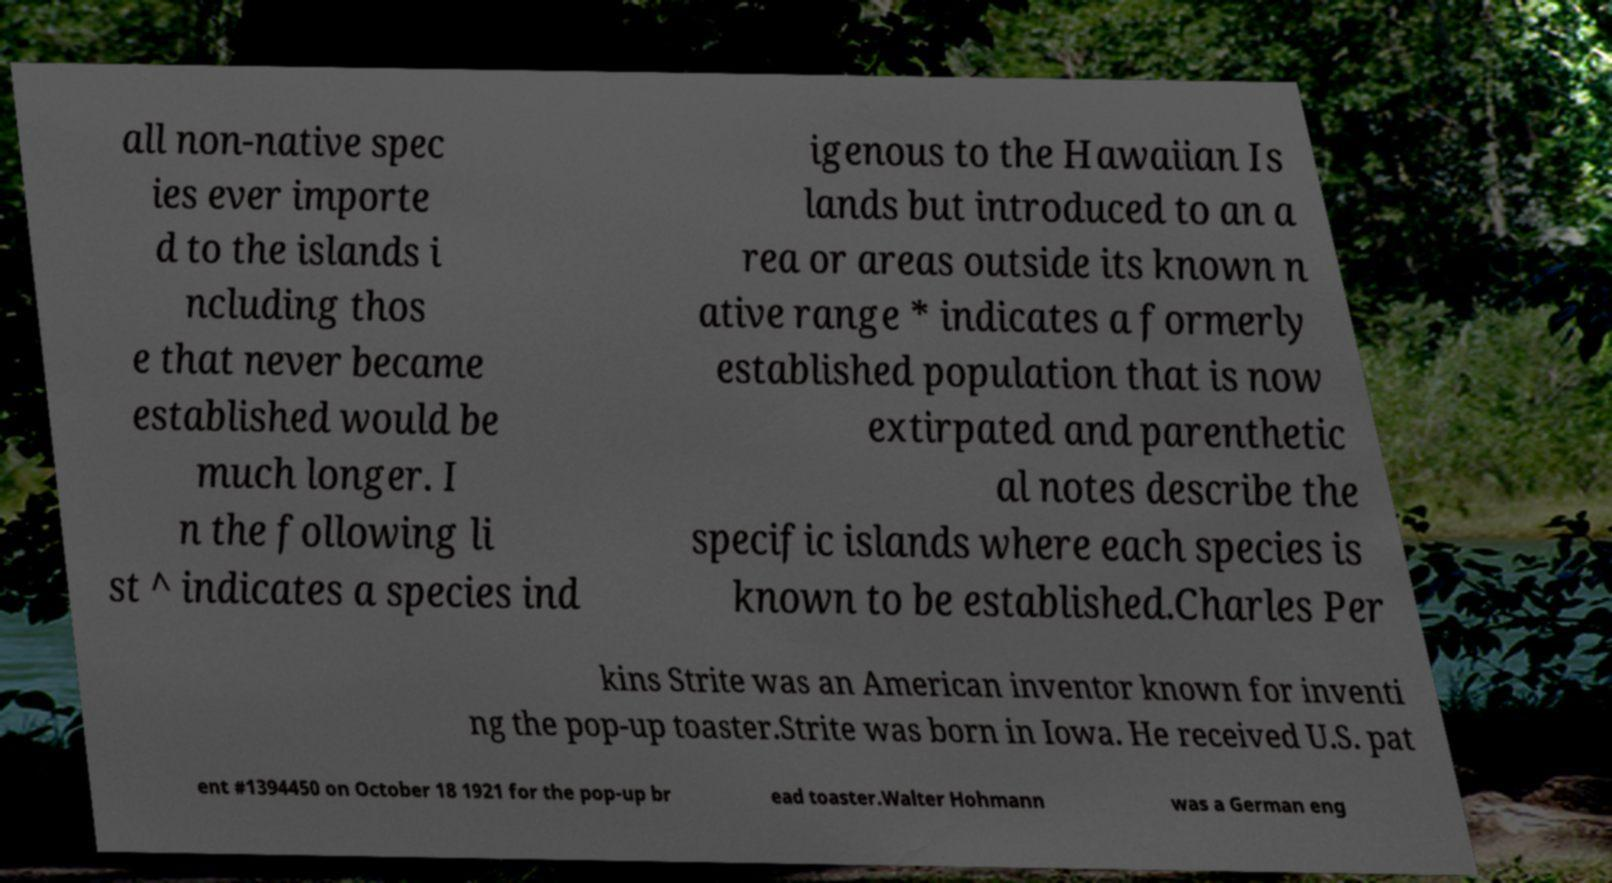Could you assist in decoding the text presented in this image and type it out clearly? all non-native spec ies ever importe d to the islands i ncluding thos e that never became established would be much longer. I n the following li st ^ indicates a species ind igenous to the Hawaiian Is lands but introduced to an a rea or areas outside its known n ative range * indicates a formerly established population that is now extirpated and parenthetic al notes describe the specific islands where each species is known to be established.Charles Per kins Strite was an American inventor known for inventi ng the pop-up toaster.Strite was born in Iowa. He received U.S. pat ent #1394450 on October 18 1921 for the pop-up br ead toaster.Walter Hohmann was a German eng 